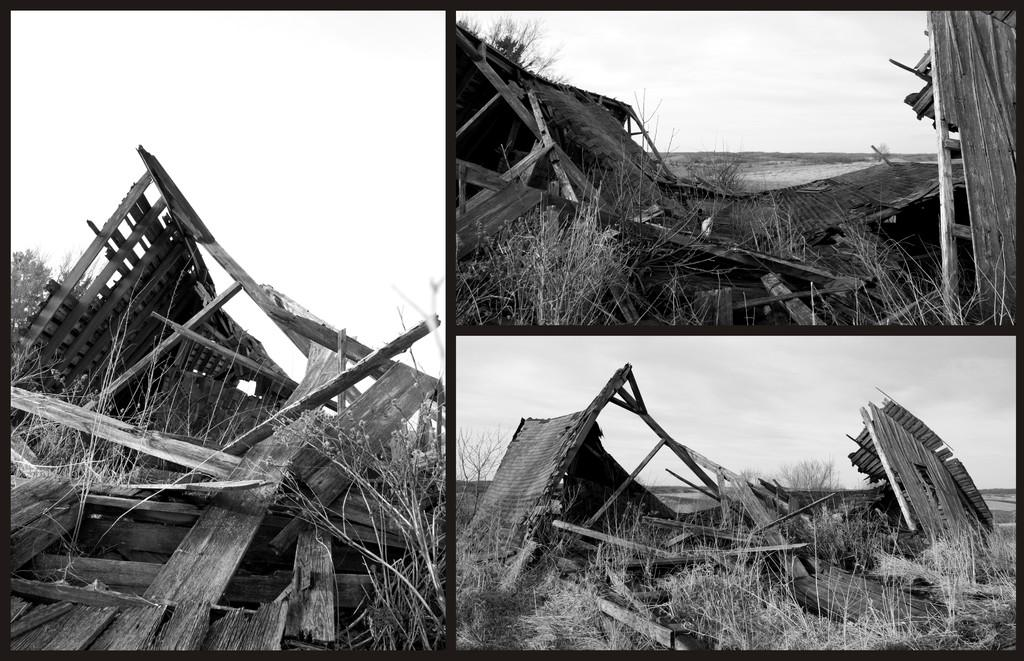What is the main subject of the image? The main subject of the image is a broken building. What can be seen in the background of the image? There is sky visible in the background of the image. What type of vegetation is present in the image? There are grasses in the image. How does the wealth of the building's owner affect the image? The image does not provide any information about the wealth of the building's owner, so it cannot be determined how it affects the image. 